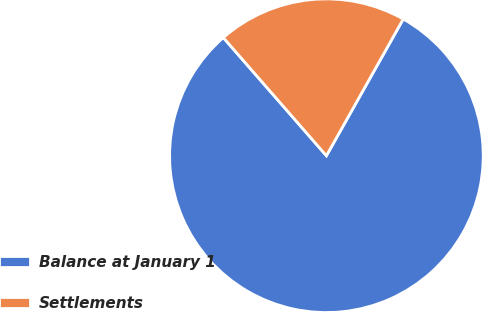Convert chart. <chart><loc_0><loc_0><loc_500><loc_500><pie_chart><fcel>Balance at January 1<fcel>Settlements<nl><fcel>80.43%<fcel>19.57%<nl></chart> 